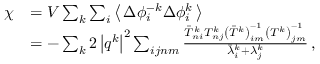Convert formula to latex. <formula><loc_0><loc_0><loc_500><loc_500>\begin{array} { r l } { \chi } & { = V \sum _ { k } \sum _ { i } \left \langle \, \Delta \phi _ { i } ^ { - k } \Delta \phi _ { i } ^ { k } \, \right \rangle } \\ & { = - \sum _ { k } 2 \left | q ^ { k } \right | ^ { 2 } \sum _ { i j n m } \frac { \bar { T } _ { n i } ^ { k } T _ { n j } ^ { k } \left ( \bar { T } ^ { k } \right ) _ { i m } ^ { - 1 } \left ( T ^ { k } \right ) _ { j m } ^ { - 1 } } { \bar { \lambda } _ { i } ^ { k } + \lambda _ { j } ^ { k } } \, , } \end{array}</formula> 